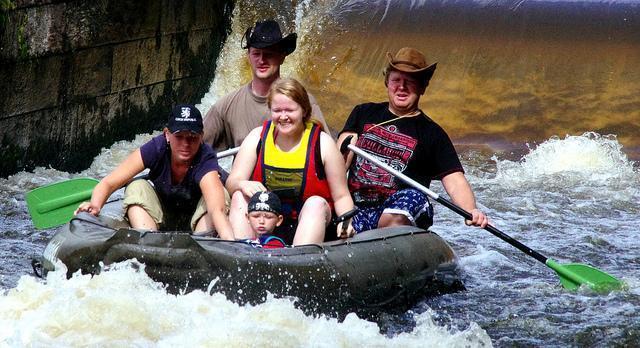What is this boat called?
From the following four choices, select the correct answer to address the question.
Options: Lifeboat, ship, inner tube, raft. Raft. 